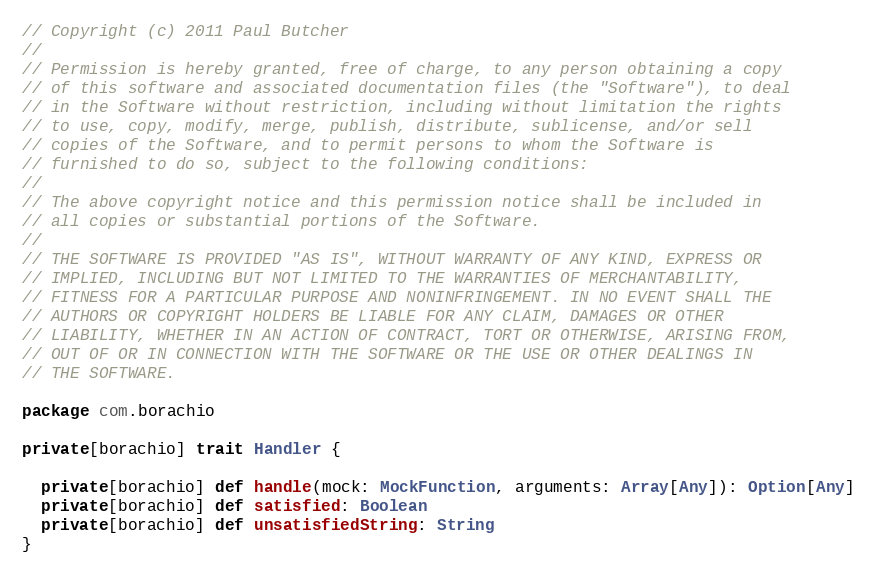Convert code to text. <code><loc_0><loc_0><loc_500><loc_500><_Scala_>// Copyright (c) 2011 Paul Butcher
// 
// Permission is hereby granted, free of charge, to any person obtaining a copy
// of this software and associated documentation files (the "Software"), to deal
// in the Software without restriction, including without limitation the rights
// to use, copy, modify, merge, publish, distribute, sublicense, and/or sell
// copies of the Software, and to permit persons to whom the Software is
// furnished to do so, subject to the following conditions:
// 
// The above copyright notice and this permission notice shall be included in
// all copies or substantial portions of the Software.
// 
// THE SOFTWARE IS PROVIDED "AS IS", WITHOUT WARRANTY OF ANY KIND, EXPRESS OR
// IMPLIED, INCLUDING BUT NOT LIMITED TO THE WARRANTIES OF MERCHANTABILITY,
// FITNESS FOR A PARTICULAR PURPOSE AND NONINFRINGEMENT. IN NO EVENT SHALL THE
// AUTHORS OR COPYRIGHT HOLDERS BE LIABLE FOR ANY CLAIM, DAMAGES OR OTHER
// LIABILITY, WHETHER IN AN ACTION OF CONTRACT, TORT OR OTHERWISE, ARISING FROM,
// OUT OF OR IN CONNECTION WITH THE SOFTWARE OR THE USE OR OTHER DEALINGS IN
// THE SOFTWARE.

package com.borachio

private[borachio] trait Handler {
  
  private[borachio] def handle(mock: MockFunction, arguments: Array[Any]): Option[Any]
  private[borachio] def satisfied: Boolean
  private[borachio] def unsatisfiedString: String
}
</code> 